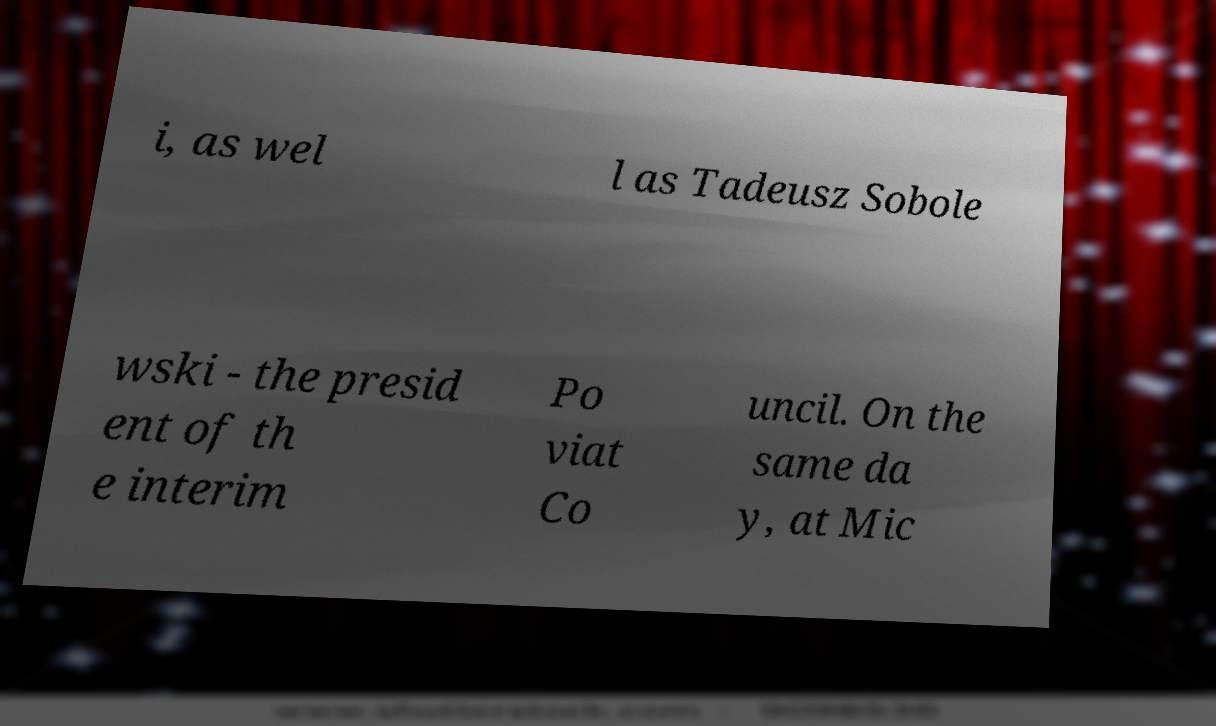What messages or text are displayed in this image? I need them in a readable, typed format. i, as wel l as Tadeusz Sobole wski - the presid ent of th e interim Po viat Co uncil. On the same da y, at Mic 